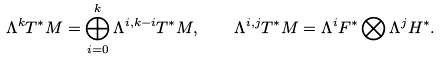<formula> <loc_0><loc_0><loc_500><loc_500>\Lambda ^ { k } T ^ { * } M = \bigoplus _ { i = 0 } ^ { k } \Lambda ^ { i , k - i } T ^ { * } M , \quad \Lambda ^ { i , j } T ^ { * } M = \Lambda ^ { i } F ^ { * } \bigotimes \Lambda ^ { j } H ^ { * } .</formula> 